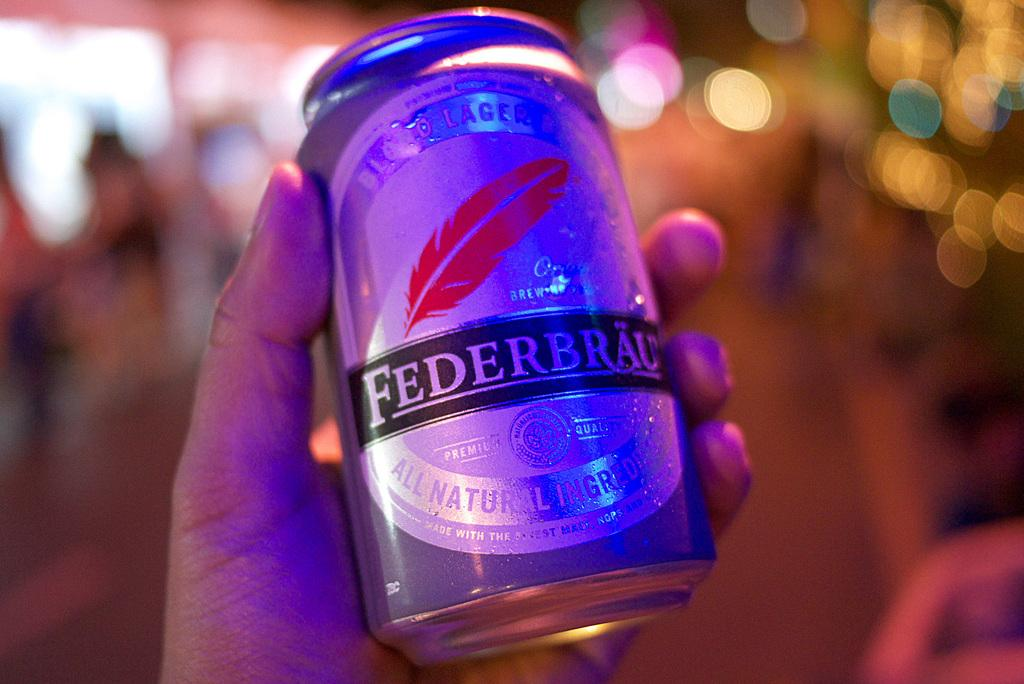<image>
Summarize the visual content of the image. a can in someones hand that is labeled 'federbrau' 